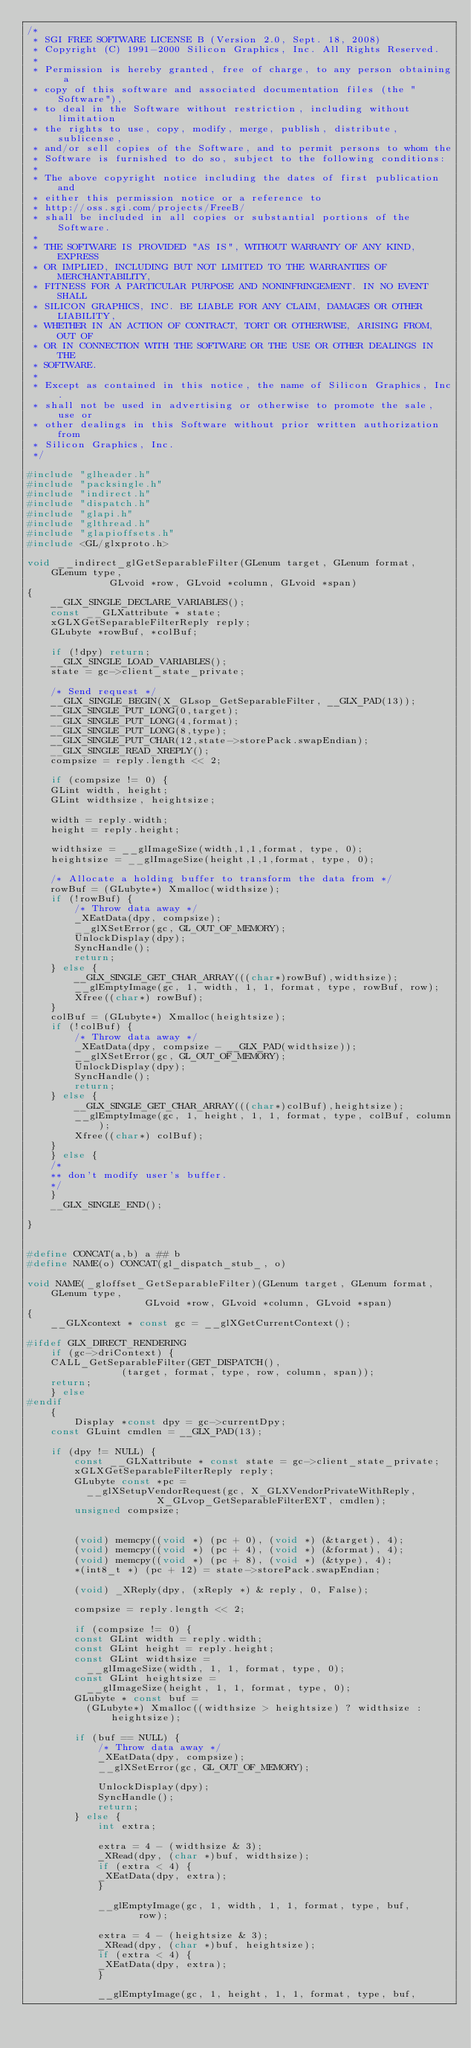Convert code to text. <code><loc_0><loc_0><loc_500><loc_500><_C_>/*
 * SGI FREE SOFTWARE LICENSE B (Version 2.0, Sept. 18, 2008)
 * Copyright (C) 1991-2000 Silicon Graphics, Inc. All Rights Reserved.
 *
 * Permission is hereby granted, free of charge, to any person obtaining a
 * copy of this software and associated documentation files (the "Software"),
 * to deal in the Software without restriction, including without limitation
 * the rights to use, copy, modify, merge, publish, distribute, sublicense,
 * and/or sell copies of the Software, and to permit persons to whom the
 * Software is furnished to do so, subject to the following conditions:
 *
 * The above copyright notice including the dates of first publication and
 * either this permission notice or a reference to
 * http://oss.sgi.com/projects/FreeB/
 * shall be included in all copies or substantial portions of the Software.
 *
 * THE SOFTWARE IS PROVIDED "AS IS", WITHOUT WARRANTY OF ANY KIND, EXPRESS
 * OR IMPLIED, INCLUDING BUT NOT LIMITED TO THE WARRANTIES OF MERCHANTABILITY,
 * FITNESS FOR A PARTICULAR PURPOSE AND NONINFRINGEMENT. IN NO EVENT SHALL
 * SILICON GRAPHICS, INC. BE LIABLE FOR ANY CLAIM, DAMAGES OR OTHER LIABILITY,
 * WHETHER IN AN ACTION OF CONTRACT, TORT OR OTHERWISE, ARISING FROM, OUT OF
 * OR IN CONNECTION WITH THE SOFTWARE OR THE USE OR OTHER DEALINGS IN THE
 * SOFTWARE.
 *
 * Except as contained in this notice, the name of Silicon Graphics, Inc.
 * shall not be used in advertising or otherwise to promote the sale, use or
 * other dealings in this Software without prior written authorization from
 * Silicon Graphics, Inc.
 */

#include "glheader.h"
#include "packsingle.h"
#include "indirect.h"
#include "dispatch.h"
#include "glapi.h"
#include "glthread.h"
#include "glapioffsets.h"
#include <GL/glxproto.h>

void __indirect_glGetSeparableFilter(GLenum target, GLenum format, GLenum type,
			  GLvoid *row, GLvoid *column, GLvoid *span)
{
    __GLX_SINGLE_DECLARE_VARIABLES();
    const __GLXattribute * state;
    xGLXGetSeparableFilterReply reply;
    GLubyte *rowBuf, *colBuf;

    if (!dpy) return;
    __GLX_SINGLE_LOAD_VARIABLES();
    state = gc->client_state_private;

    /* Send request */
    __GLX_SINGLE_BEGIN(X_GLsop_GetSeparableFilter, __GLX_PAD(13));
    __GLX_SINGLE_PUT_LONG(0,target);
    __GLX_SINGLE_PUT_LONG(4,format);
    __GLX_SINGLE_PUT_LONG(8,type);
    __GLX_SINGLE_PUT_CHAR(12,state->storePack.swapEndian);
    __GLX_SINGLE_READ_XREPLY();
    compsize = reply.length << 2;

    if (compsize != 0) {
	GLint width, height;
	GLint widthsize, heightsize;

	width = reply.width;
	height = reply.height;

	widthsize = __glImageSize(width,1,1,format, type, 0);
	heightsize = __glImageSize(height,1,1,format, type, 0);

	/* Allocate a holding buffer to transform the data from */
	rowBuf = (GLubyte*) Xmalloc(widthsize);
	if (!rowBuf) {
	    /* Throw data away */
	    _XEatData(dpy, compsize);
	    __glXSetError(gc, GL_OUT_OF_MEMORY);
	    UnlockDisplay(dpy);
	    SyncHandle();
	    return;
	} else {
	    __GLX_SINGLE_GET_CHAR_ARRAY(((char*)rowBuf),widthsize);
	    __glEmptyImage(gc, 1, width, 1, 1, format, type, rowBuf, row);
	    Xfree((char*) rowBuf);
	}
	colBuf = (GLubyte*) Xmalloc(heightsize);
	if (!colBuf) {
	    /* Throw data away */
	    _XEatData(dpy, compsize - __GLX_PAD(widthsize));
	    __glXSetError(gc, GL_OUT_OF_MEMORY);
	    UnlockDisplay(dpy);
	    SyncHandle();
	    return;
	} else {
	    __GLX_SINGLE_GET_CHAR_ARRAY(((char*)colBuf),heightsize);
	    __glEmptyImage(gc, 1, height, 1, 1, format, type, colBuf, column);
	    Xfree((char*) colBuf);
	}
    } else {
	/*
	** don't modify user's buffer.
	*/
    }
    __GLX_SINGLE_END();
    
}


#define CONCAT(a,b) a ## b
#define NAME(o) CONCAT(gl_dispatch_stub_, o)

void NAME(_gloffset_GetSeparableFilter)(GLenum target, GLenum format, GLenum type,
					GLvoid *row, GLvoid *column, GLvoid *span)
{
    __GLXcontext * const gc = __glXGetCurrentContext();

#ifdef GLX_DIRECT_RENDERING
    if (gc->driContext) {
	CALL_GetSeparableFilter(GET_DISPATCH(),
				(target, format, type, row, column, span));
	return;
    } else 
#endif
    {
        Display *const dpy = gc->currentDpy;
	const GLuint cmdlen = __GLX_PAD(13);

	if (dpy != NULL) {
	    const __GLXattribute * const state = gc->client_state_private;
	    xGLXGetSeparableFilterReply reply;
	    GLubyte const *pc =
	      __glXSetupVendorRequest(gc, X_GLXVendorPrivateWithReply,
				      X_GLvop_GetSeparableFilterEXT, cmdlen);
	    unsigned compsize;


	    (void) memcpy((void *) (pc + 0), (void *) (&target), 4);
	    (void) memcpy((void *) (pc + 4), (void *) (&format), 4);
	    (void) memcpy((void *) (pc + 8), (void *) (&type), 4);
	    *(int8_t *) (pc + 12) = state->storePack.swapEndian;

	    (void) _XReply(dpy, (xReply *) & reply, 0, False);

	    compsize = reply.length << 2;

	    if (compsize != 0) {
		const GLint width = reply.width;
		const GLint height = reply.height;
		const GLint widthsize =
		  __glImageSize(width, 1, 1, format, type, 0);
		const GLint heightsize =
		  __glImageSize(height, 1, 1, format, type, 0);
		GLubyte * const buf =
		  (GLubyte*) Xmalloc((widthsize > heightsize) ? widthsize : heightsize);

		if (buf == NULL) {
		    /* Throw data away */
		    _XEatData(dpy, compsize);
		    __glXSetError(gc, GL_OUT_OF_MEMORY);

		    UnlockDisplay(dpy);
		    SyncHandle();
		    return;
		} else {
		    int extra;
		    
		    extra = 4 - (widthsize & 3);
		    _XRead(dpy, (char *)buf, widthsize);
		    if (extra < 4) {
			_XEatData(dpy, extra);
		    }

		    __glEmptyImage(gc, 1, width, 1, 1, format, type, buf,
				   row);

		    extra = 4 - (heightsize & 3);
		    _XRead(dpy, (char *)buf, heightsize);
		    if (extra < 4) {
			_XEatData(dpy, extra);
		    }

		    __glEmptyImage(gc, 1, height, 1, 1, format, type, buf,</code> 